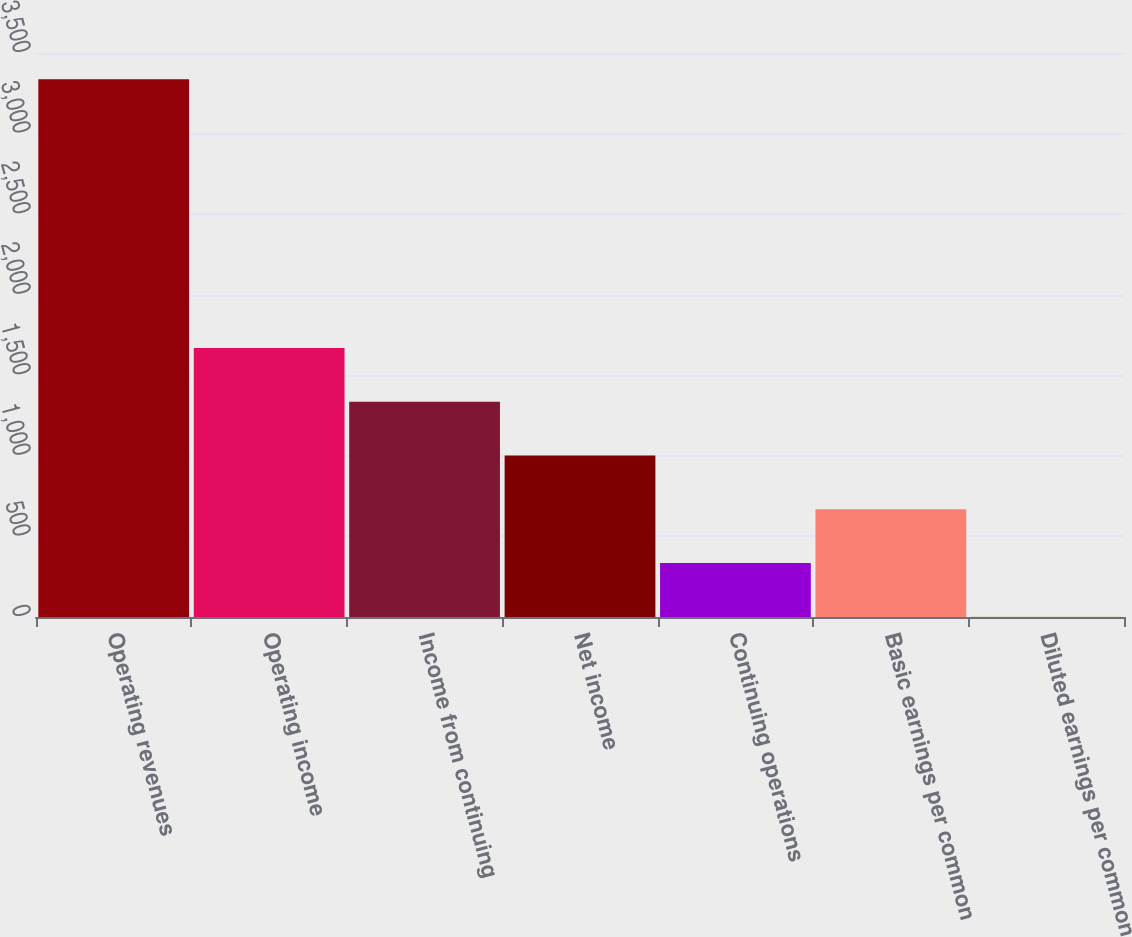Convert chart to OTSL. <chart><loc_0><loc_0><loc_500><loc_500><bar_chart><fcel>Operating revenues<fcel>Operating income<fcel>Income from continuing<fcel>Net income<fcel>Continuing operations<fcel>Basic earnings per common<fcel>Diluted earnings per common<nl><fcel>3337<fcel>1669.06<fcel>1335.48<fcel>1001.9<fcel>334.74<fcel>668.32<fcel>1.16<nl></chart> 